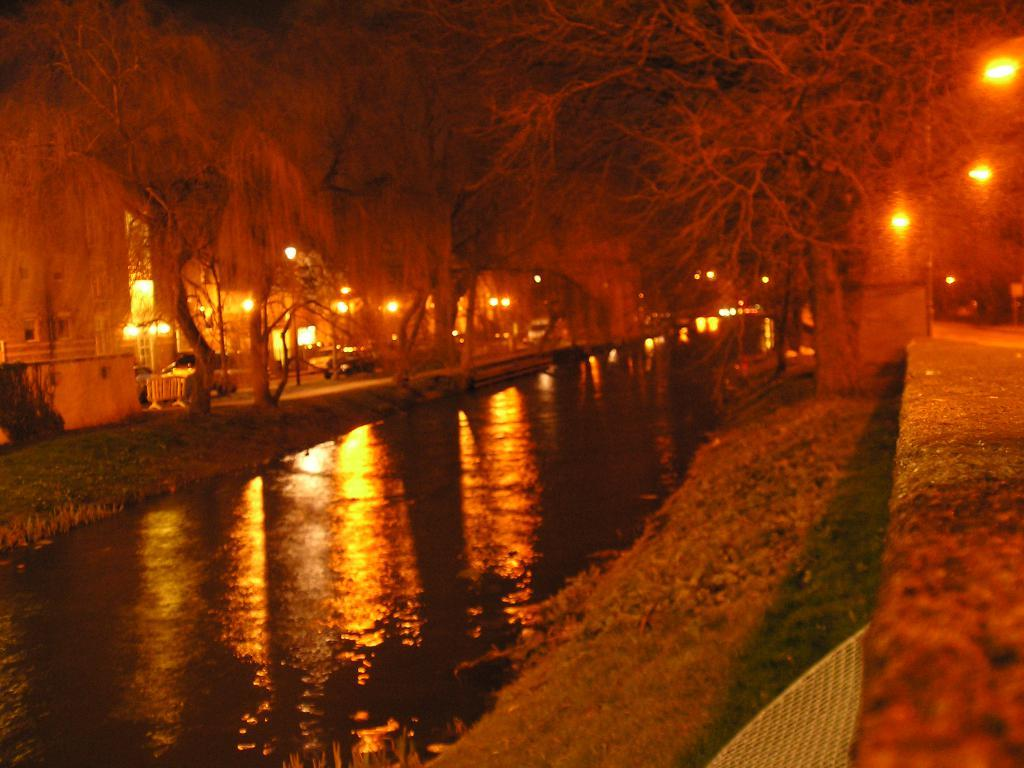What is visible in the image that is not a solid structure? Water is visible in the image. What type of natural elements can be seen in the image? There are trees in the image. What type of man-made objects are present in the image? Vehicles and buildings are present in the image. What type of artificial light sources can be seen in the image? There are lights in the image. How many glasses of wine are visible in the image? There is no wine present in the image. What type of spiders can be seen crawling on the buildings in the image? There are no spiders visible in the image. 